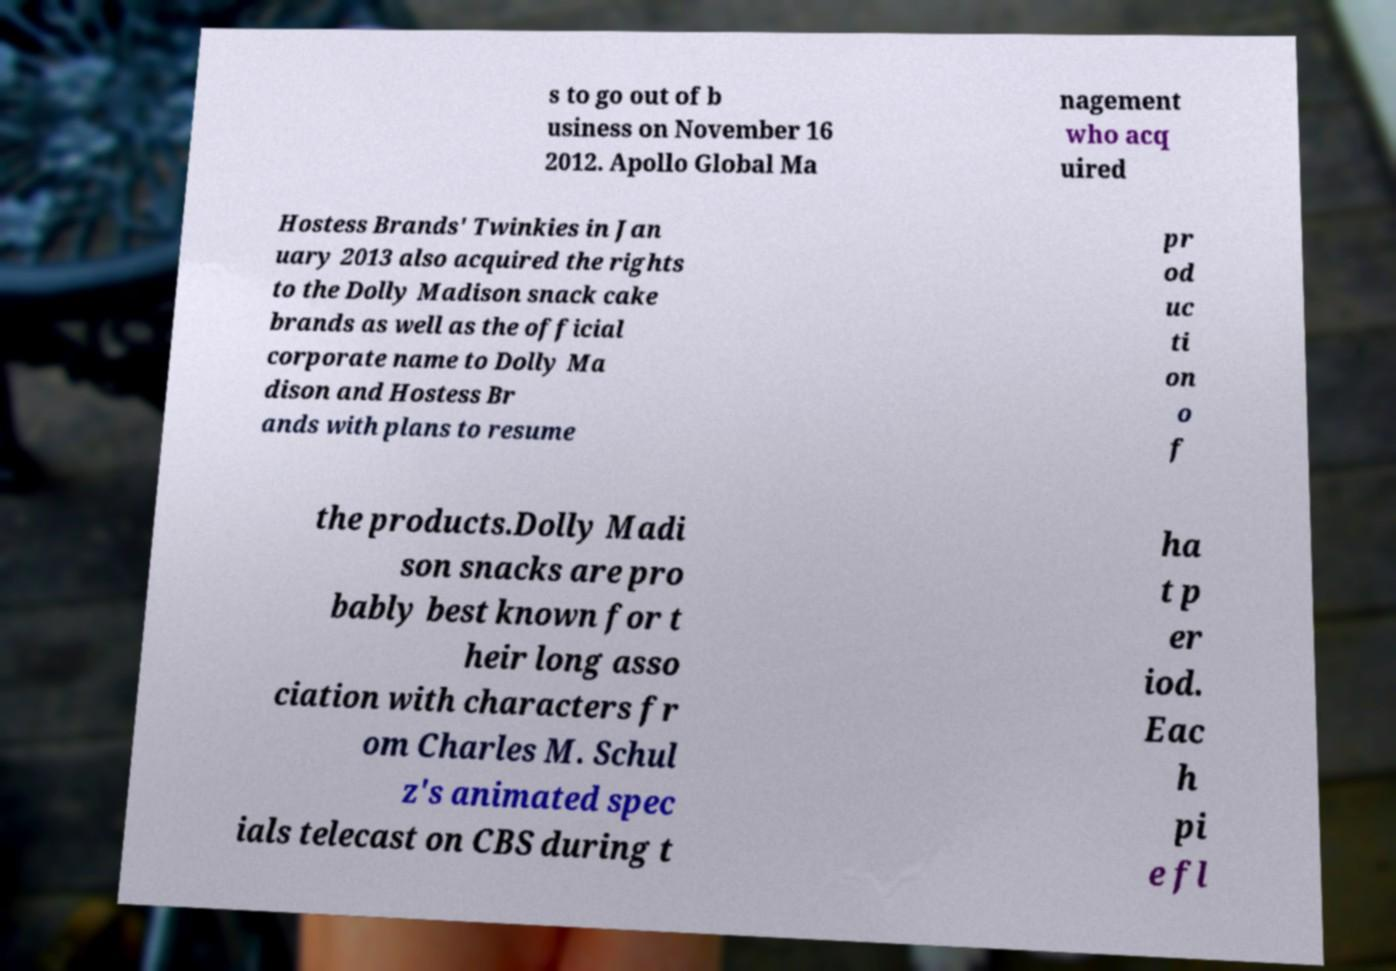Could you assist in decoding the text presented in this image and type it out clearly? s to go out of b usiness on November 16 2012. Apollo Global Ma nagement who acq uired Hostess Brands' Twinkies in Jan uary 2013 also acquired the rights to the Dolly Madison snack cake brands as well as the official corporate name to Dolly Ma dison and Hostess Br ands with plans to resume pr od uc ti on o f the products.Dolly Madi son snacks are pro bably best known for t heir long asso ciation with characters fr om Charles M. Schul z's animated spec ials telecast on CBS during t ha t p er iod. Eac h pi e fl 